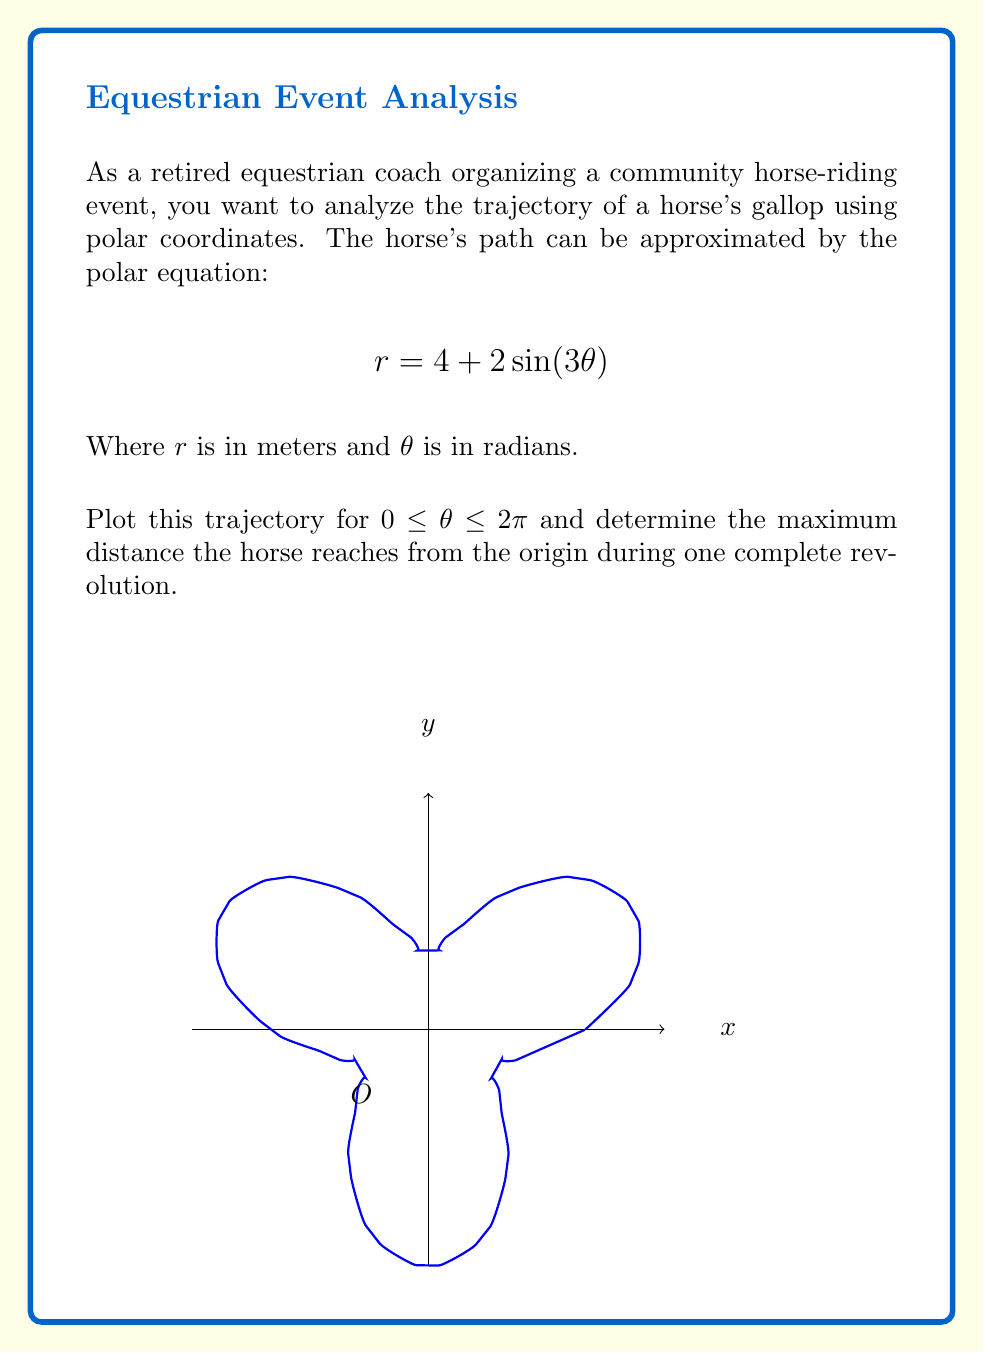Could you help me with this problem? To solve this problem, we'll follow these steps:

1) The given polar equation is $r = 4 + 2\sin(3\theta)$. This represents the distance $r$ from the origin at any angle $\theta$.

2) To find the maximum distance, we need to find the maximum value of $r$. This occurs when $\sin(3\theta)$ is at its maximum, which is 1.

3) When $\sin(3\theta) = 1$, the equation becomes:

   $$r_{max} = 4 + 2(1) = 6$$

4) Therefore, the maximum distance from the origin is 6 meters.

5) To verify, we can consider the minimum value when $\sin(3\theta) = -1$:

   $$r_{min} = 4 + 2(-1) = 2$$

6) The plot shows that the horse's path oscillates between 2 and 6 meters from the origin, confirming our calculation.

7) The shape of the trajectory is a trefoil, completing three "loops" in one full revolution due to the $\sin(3\theta)$ term.
Answer: 6 meters 